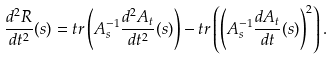<formula> <loc_0><loc_0><loc_500><loc_500>\frac { d ^ { 2 } R } { d t ^ { 2 } } ( s ) = t r \left ( A _ { s } ^ { - 1 } \frac { d ^ { 2 } A _ { t } } { d t ^ { 2 } } ( s ) \right ) - t r \left ( \left ( A _ { s } ^ { - 1 } \frac { d A _ { t } } { d t } ( s ) \right ) ^ { 2 } \right ) .</formula> 